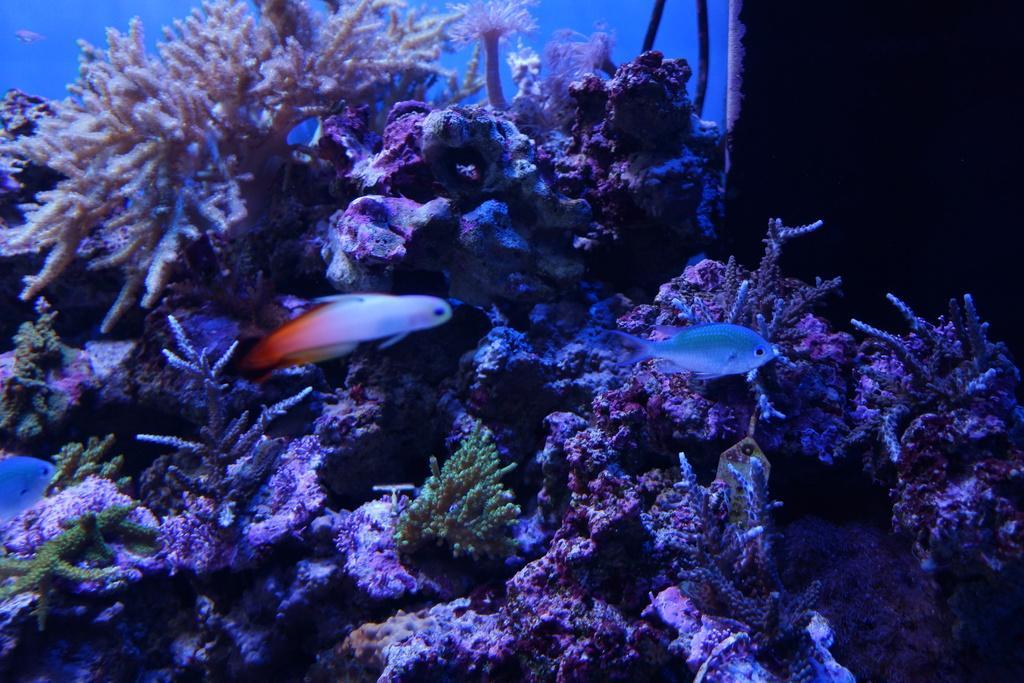Please provide a concise description of this image. In this picture I can observe underwater environment. I can observe fish swimming in the water. 